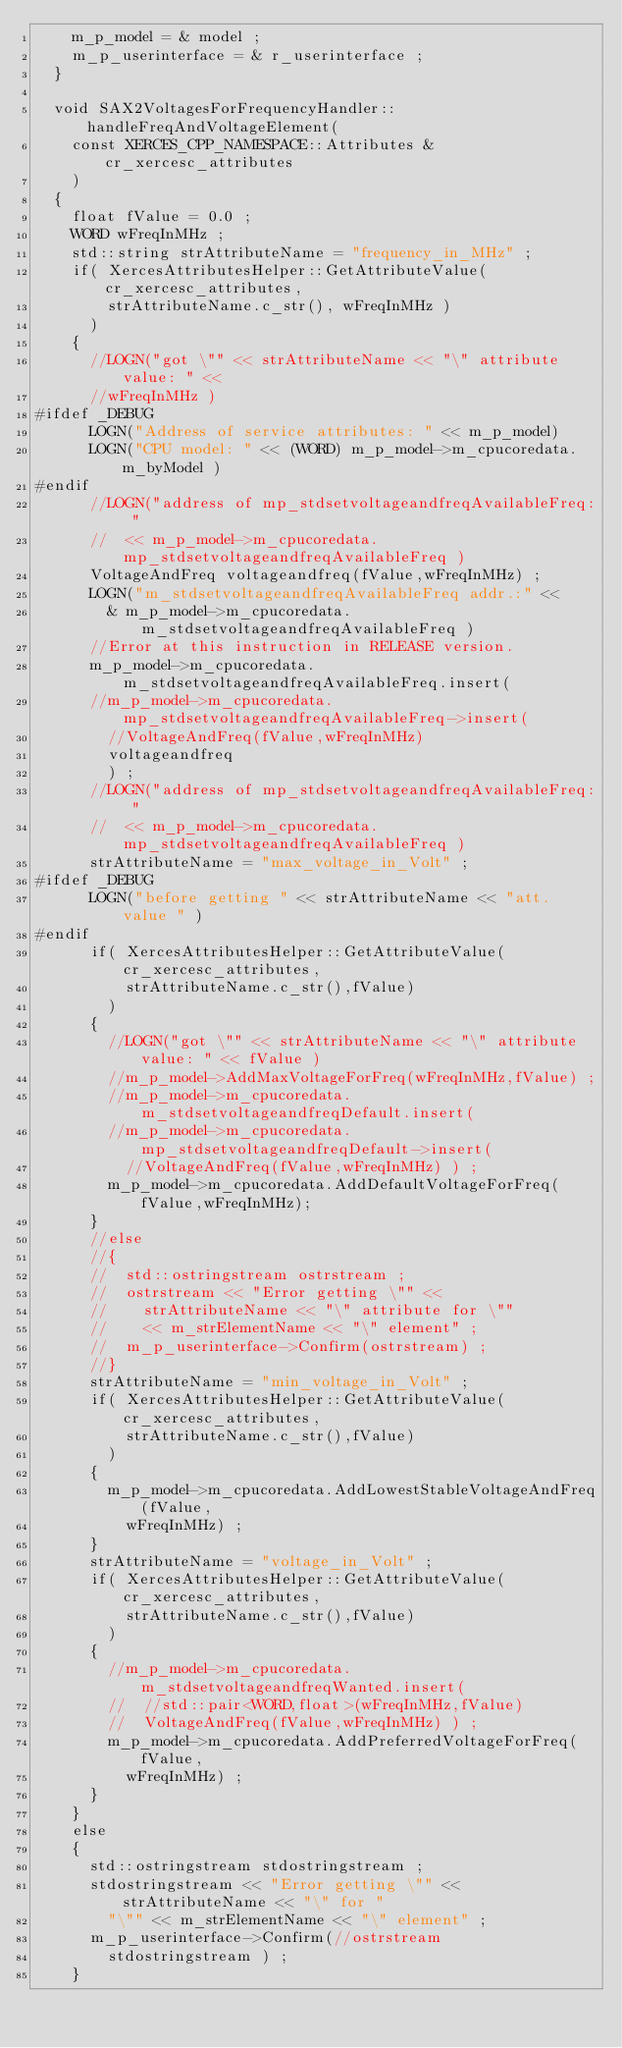Convert code to text. <code><loc_0><loc_0><loc_500><loc_500><_C++_>    m_p_model = & model ;
    m_p_userinterface = & r_userinterface ;
  }

  void SAX2VoltagesForFrequencyHandler::handleFreqAndVoltageElement(
    const XERCES_CPP_NAMESPACE::Attributes & cr_xercesc_attributes
    )
  {
    float fValue = 0.0 ;
    WORD wFreqInMHz ;
    std::string strAttributeName = "frequency_in_MHz" ;
    if( XercesAttributesHelper::GetAttributeValue(cr_xercesc_attributes,
        strAttributeName.c_str(), wFreqInMHz )
      )
    {
      //LOGN("got \"" << strAttributeName << "\" attribute value: " <<
      //wFreqInMHz )
#ifdef _DEBUG
      LOGN("Address of service attributes: " << m_p_model)
      LOGN("CPU model: " << (WORD) m_p_model->m_cpucoredata.m_byModel )
#endif
      //LOGN("address of mp_stdsetvoltageandfreqAvailableFreq: " 
      //  << m_p_model->m_cpucoredata.mp_stdsetvoltageandfreqAvailableFreq )
      VoltageAndFreq voltageandfreq(fValue,wFreqInMHz) ;
      LOGN("m_stdsetvoltageandfreqAvailableFreq addr.:" << 
        & m_p_model->m_cpucoredata.m_stdsetvoltageandfreqAvailableFreq )
      //Error at this instruction in RELEASE version.
      m_p_model->m_cpucoredata.m_stdsetvoltageandfreqAvailableFreq.insert(
      //m_p_model->m_cpucoredata.mp_stdsetvoltageandfreqAvailableFreq->insert(
        //VoltageAndFreq(fValue,wFreqInMHz) 
        voltageandfreq
        ) ;
      //LOGN("address of mp_stdsetvoltageandfreqAvailableFreq: " 
      //  << m_p_model->m_cpucoredata.mp_stdsetvoltageandfreqAvailableFreq )
      strAttributeName = "max_voltage_in_Volt" ;
#ifdef _DEBUG
      LOGN("before getting " << strAttributeName << "att. value " )
#endif
      if( XercesAttributesHelper::GetAttributeValue(cr_xercesc_attributes,
          strAttributeName.c_str(),fValue)
        )
      {
        //LOGN("got \"" << strAttributeName << "\" attribute value: " << fValue )
        //m_p_model->AddMaxVoltageForFreq(wFreqInMHz,fValue) ;
        //m_p_model->m_cpucoredata.m_stdsetvoltageandfreqDefault.insert(
        //m_p_model->m_cpucoredata.mp_stdsetvoltageandfreqDefault->insert(
          //VoltageAndFreq(fValue,wFreqInMHz) ) ;
        m_p_model->m_cpucoredata.AddDefaultVoltageForFreq(fValue,wFreqInMHz);
      }
      //else
      //{
      //  std::ostringstream ostrstream ;
      //  ostrstream << "Error getting \"" <<
      //    strAttributeName << "\" attribute for \""
      //    << m_strElementName << "\" element" ;
      //  m_p_userinterface->Confirm(ostrstream) ;
      //}
      strAttributeName = "min_voltage_in_Volt" ;
      if( XercesAttributesHelper::GetAttributeValue(cr_xercesc_attributes,
          strAttributeName.c_str(),fValue)
        )
      {
        m_p_model->m_cpucoredata.AddLowestStableVoltageAndFreq(fValue,
          wFreqInMHz) ;
      }
      strAttributeName = "voltage_in_Volt" ;
      if( XercesAttributesHelper::GetAttributeValue(cr_xercesc_attributes,
          strAttributeName.c_str(),fValue)
        )
      {
        //m_p_model->m_cpucoredata.m_stdsetvoltageandfreqWanted.insert( 
        //  //std::pair<WORD,float>(wFreqInMHz,fValue) 
        //  VoltageAndFreq(fValue,wFreqInMHz) ) ;
        m_p_model->m_cpucoredata.AddPreferredVoltageForFreq(fValue,
          wFreqInMHz) ;
      }
    }
    else
    {
      std::ostringstream stdostringstream ;
      stdostringstream << "Error getting \"" << strAttributeName << "\" for "
        "\"" << m_strElementName << "\" element" ;
      m_p_userinterface->Confirm(//ostrstream
        stdostringstream ) ;
    }</code> 